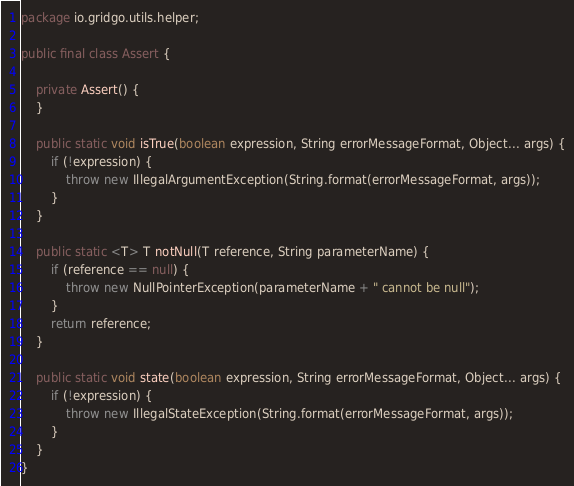Convert code to text. <code><loc_0><loc_0><loc_500><loc_500><_Java_>package io.gridgo.utils.helper;

public final class Assert {

    private Assert() {
    }

    public static void isTrue(boolean expression, String errorMessageFormat, Object... args) {
        if (!expression) {
            throw new IllegalArgumentException(String.format(errorMessageFormat, args));
        }
    }

    public static <T> T notNull(T reference, String parameterName) {
        if (reference == null) {
            throw new NullPointerException(parameterName + " cannot be null");
        }
        return reference;
    }

    public static void state(boolean expression, String errorMessageFormat, Object... args) {
        if (!expression) {
            throw new IllegalStateException(String.format(errorMessageFormat, args));
        }
    }
}
</code> 